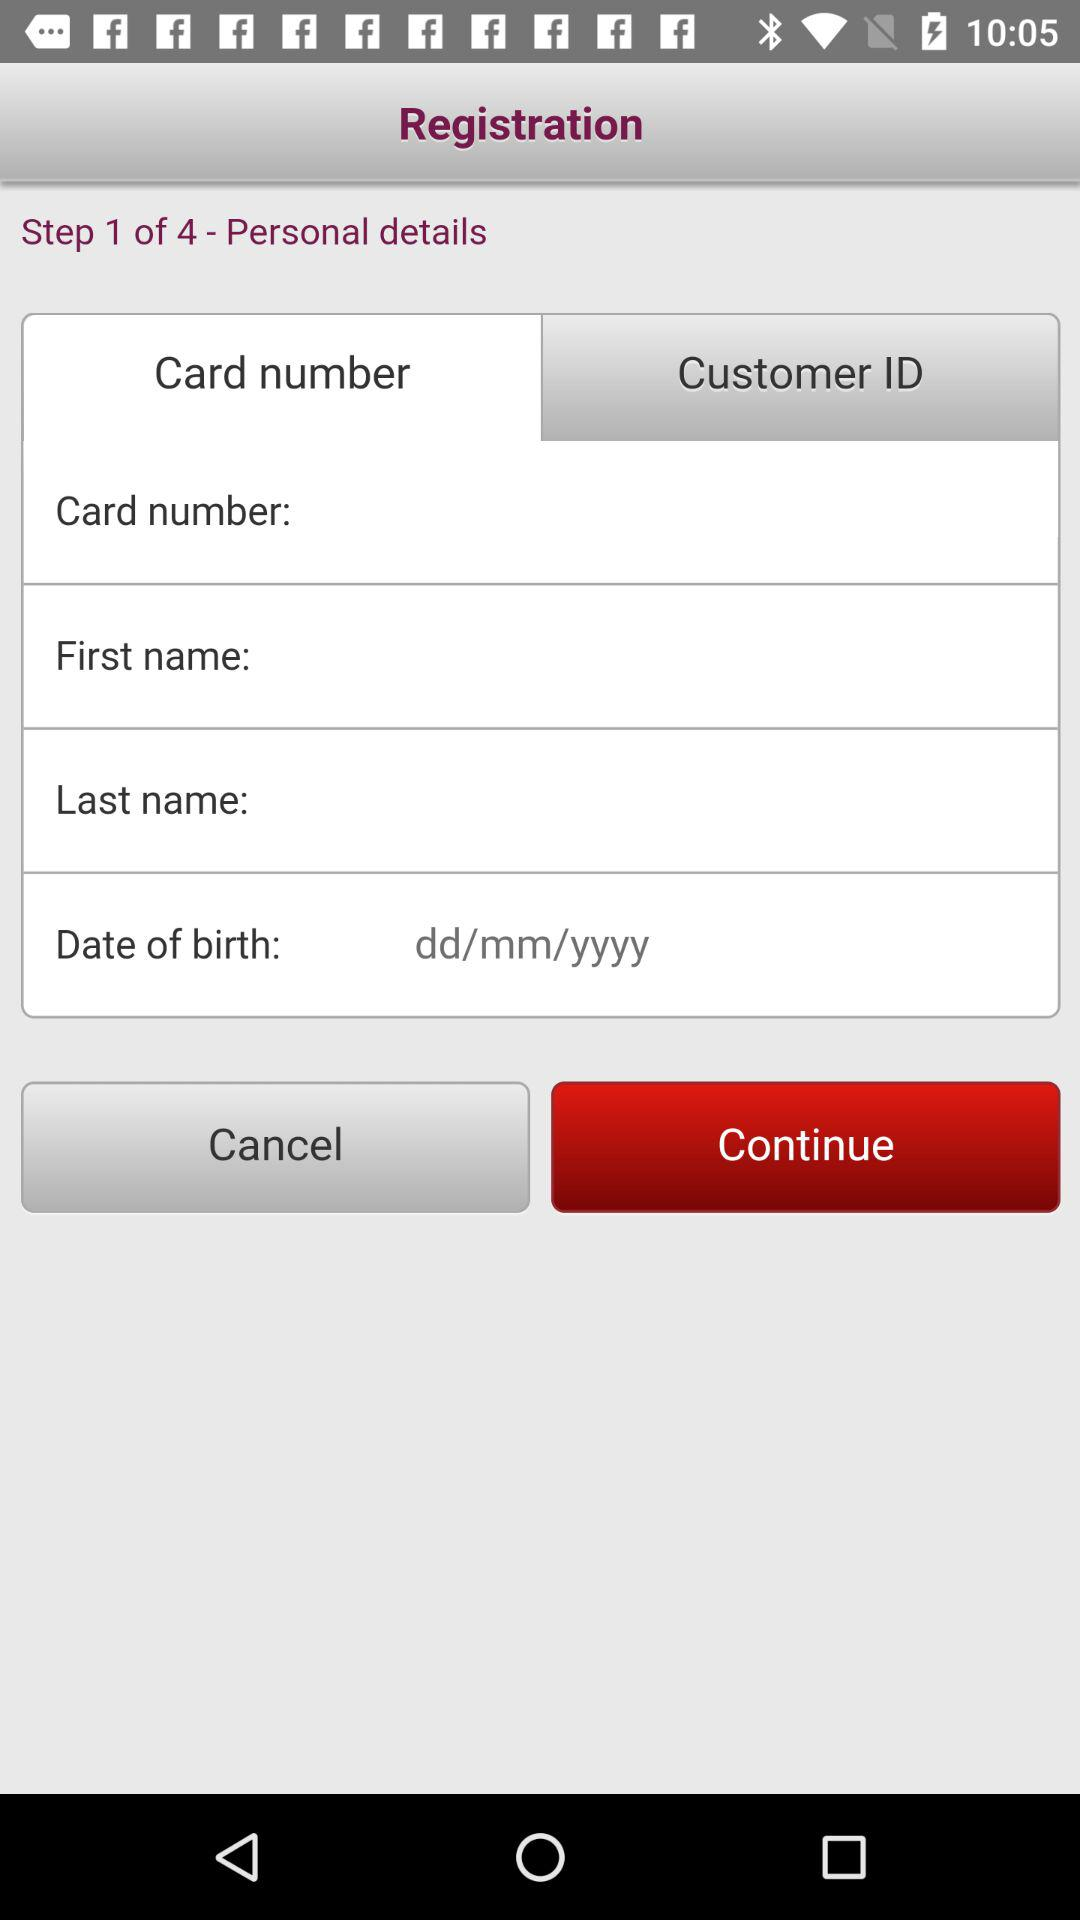How many steps are there for registration? There are 4 steps for registration. 